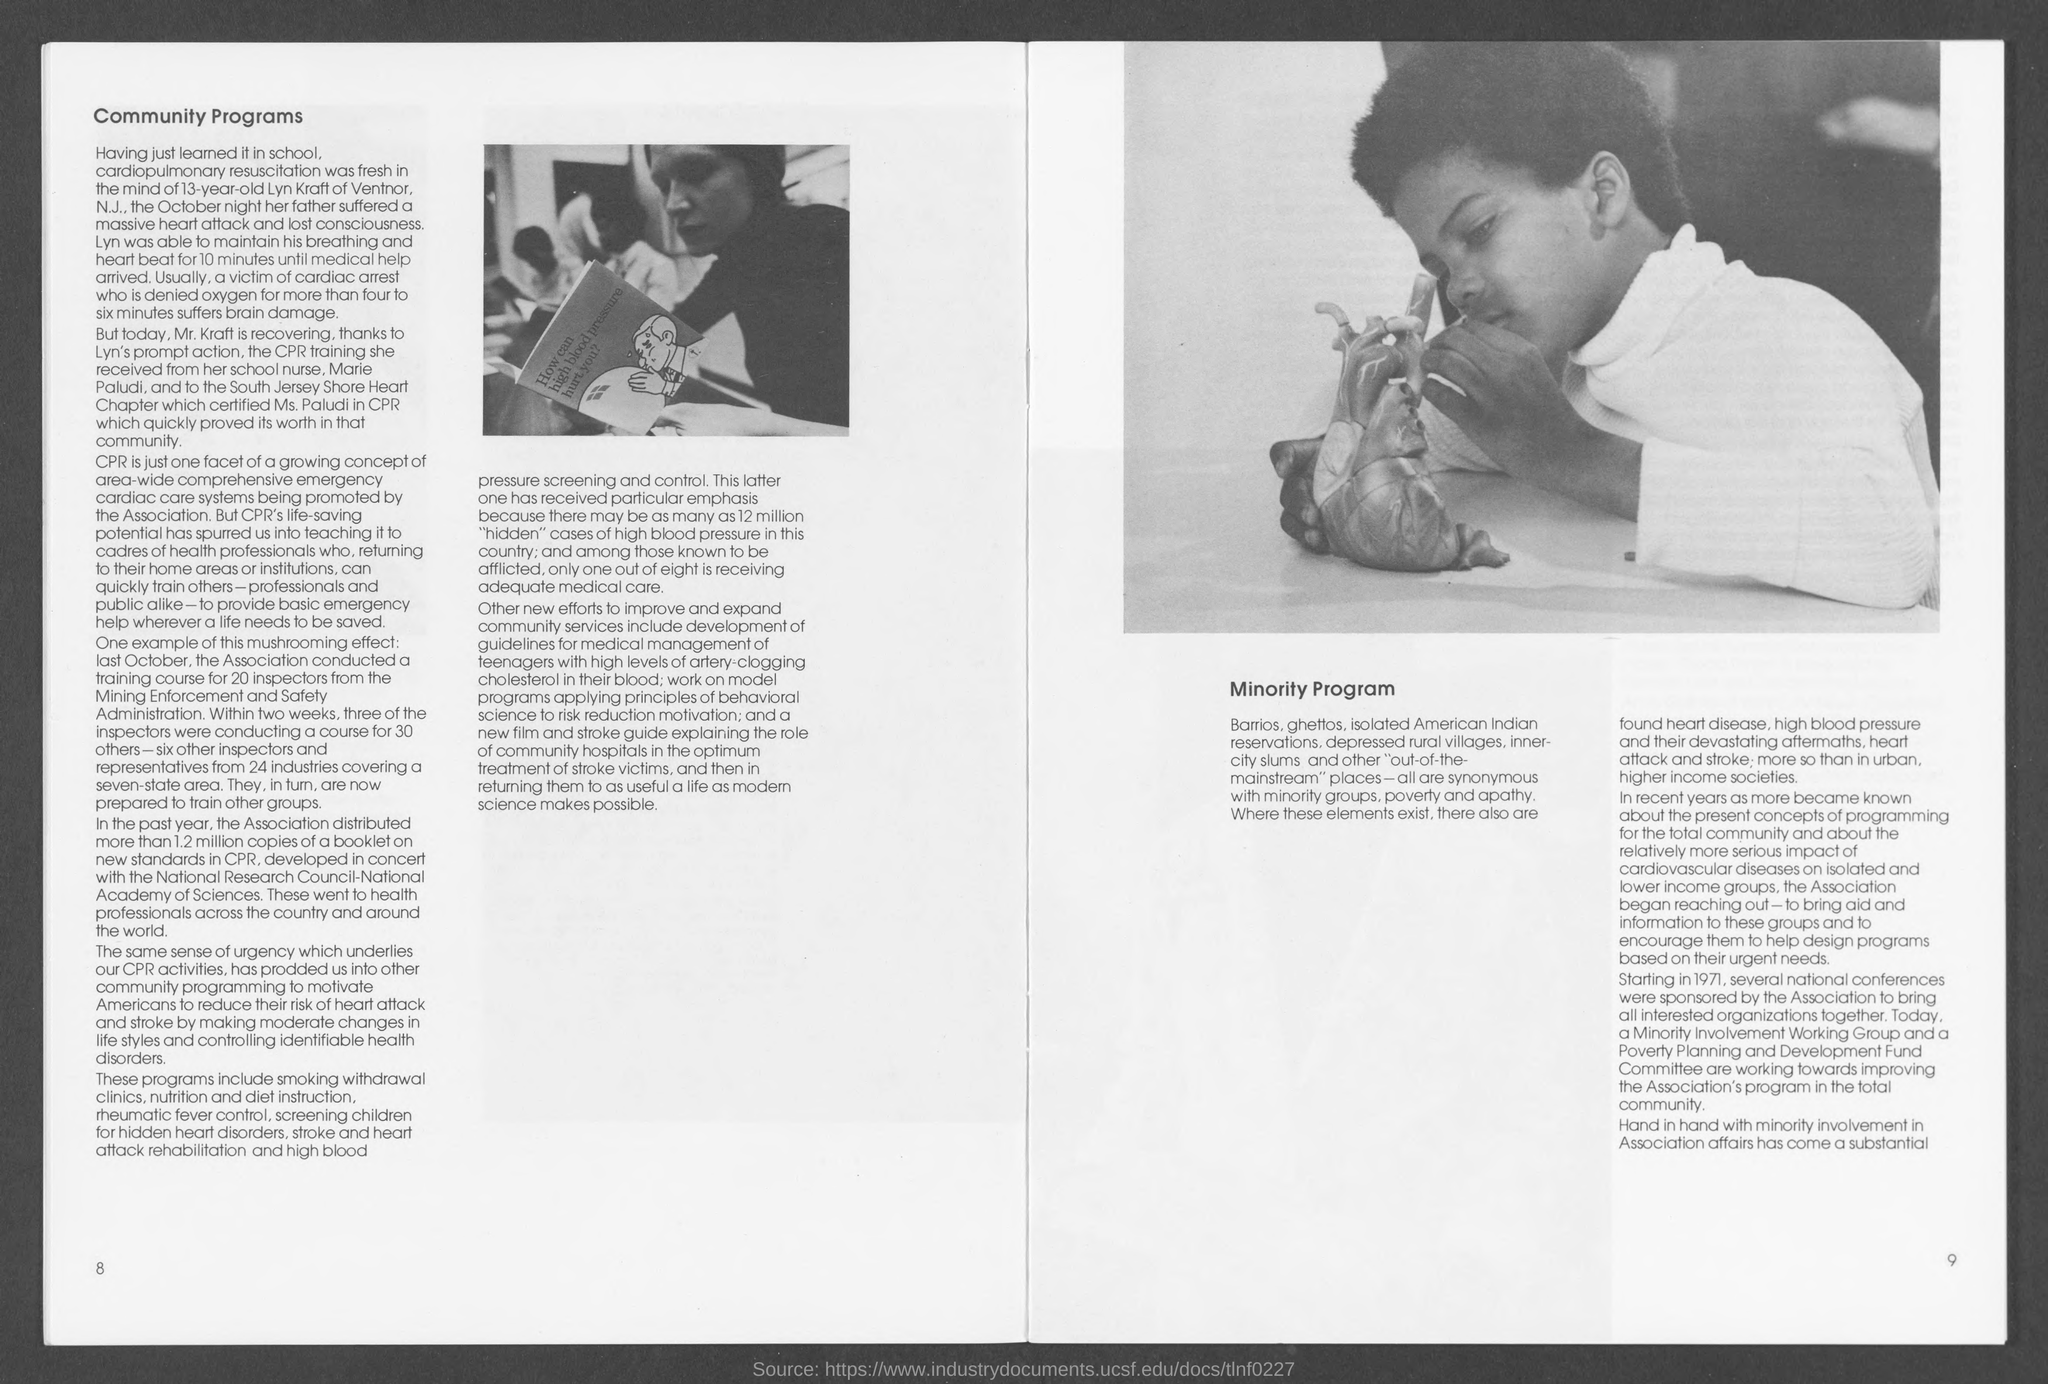What is the heading at top of left page ?
Ensure brevity in your answer.  Community Programs. What is number at bottom left page ?
Give a very brief answer. 8. What is the number at bottom right page?
Your answer should be very brief. 9. 